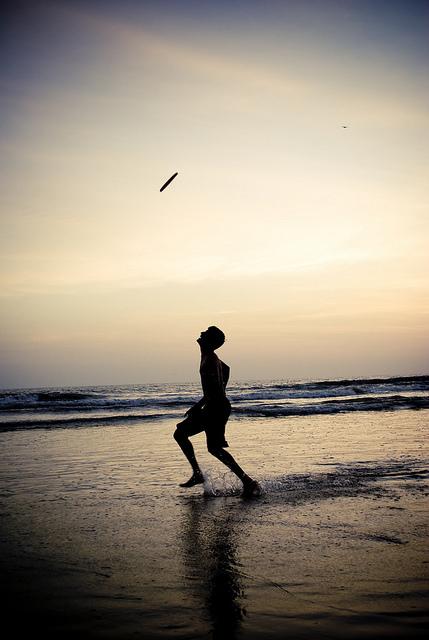What is being thrown?
Answer briefly. Frisbee. Hazy or sunny?
Short answer required. Hazy. How is the frisbee being thrown?
Give a very brief answer. Up. Is there water in this picture?
Answer briefly. Yes. 